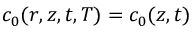Convert formula to latex. <formula><loc_0><loc_0><loc_500><loc_500>c _ { 0 } ( r , z , t , T ) = c _ { 0 } ( z , t )</formula> 